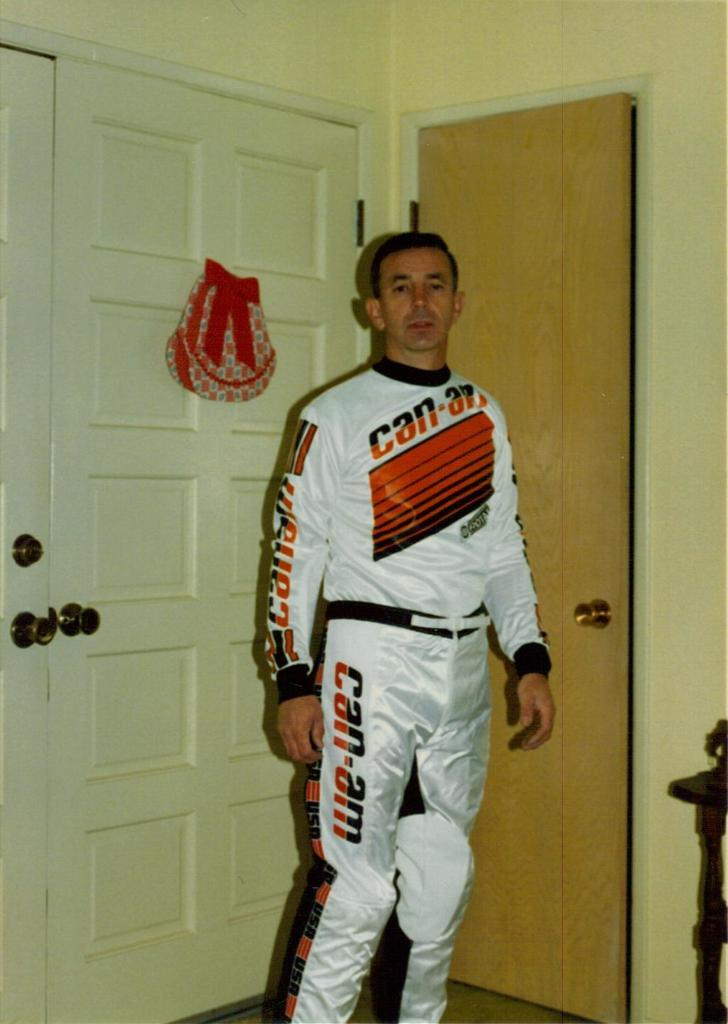<image>
Render a clear and concise summary of the photo. A man is wearing a can-am full track suit 